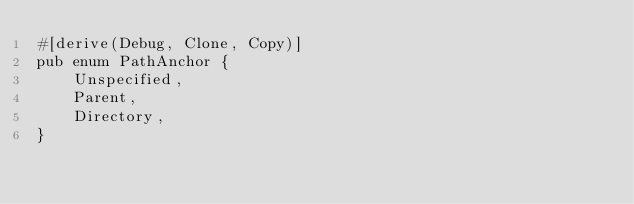<code> <loc_0><loc_0><loc_500><loc_500><_Rust_>#[derive(Debug, Clone, Copy)]
pub enum PathAnchor {
    Unspecified,
    Parent,
    Directory,
}

</code> 